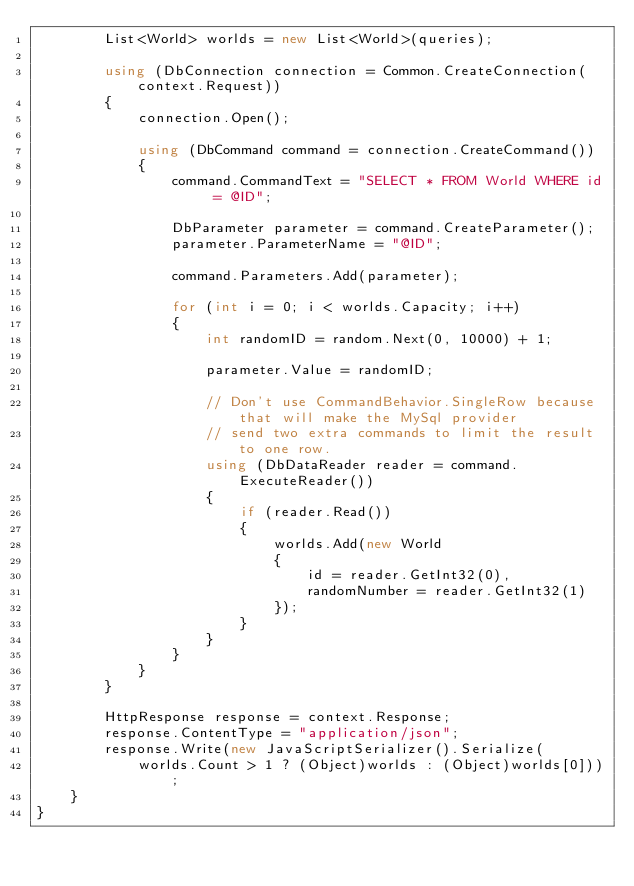Convert code to text. <code><loc_0><loc_0><loc_500><loc_500><_C#_>        List<World> worlds = new List<World>(queries);
        
        using (DbConnection connection = Common.CreateConnection(context.Request))
        {
            connection.Open();
            
            using (DbCommand command = connection.CreateCommand())
            {
                command.CommandText = "SELECT * FROM World WHERE id = @ID";

                DbParameter parameter = command.CreateParameter();
                parameter.ParameterName = "@ID";
                
                command.Parameters.Add(parameter);

                for (int i = 0; i < worlds.Capacity; i++)
                {
                    int randomID = random.Next(0, 10000) + 1;

                    parameter.Value = randomID;
                    
                    // Don't use CommandBehavior.SingleRow because that will make the MySql provider
                    // send two extra commands to limit the result to one row.
                    using (DbDataReader reader = command.ExecuteReader())
                    {
                        if (reader.Read())
                        {
                            worlds.Add(new World
                            {
                                id = reader.GetInt32(0),
                                randomNumber = reader.GetInt32(1)
                            });
                        }
                    }
                }
            }
        }
        
        HttpResponse response = context.Response;
        response.ContentType = "application/json";
        response.Write(new JavaScriptSerializer().Serialize(
            worlds.Count > 1 ? (Object)worlds : (Object)worlds[0]));
    }
}</code> 